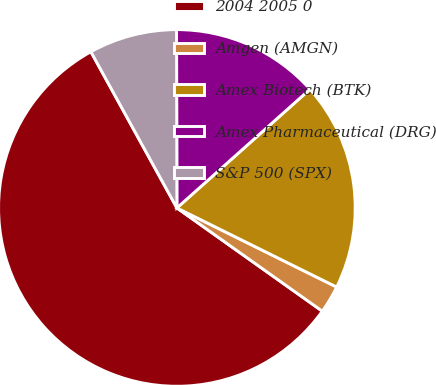Convert chart. <chart><loc_0><loc_0><loc_500><loc_500><pie_chart><fcel>2004 2005 0<fcel>Amgen (AMGN)<fcel>Amex Biotech (BTK)<fcel>Amex Pharmaceutical (DRG)<fcel>S&P 500 (SPX)<nl><fcel>57.17%<fcel>2.51%<fcel>18.91%<fcel>13.44%<fcel>7.98%<nl></chart> 